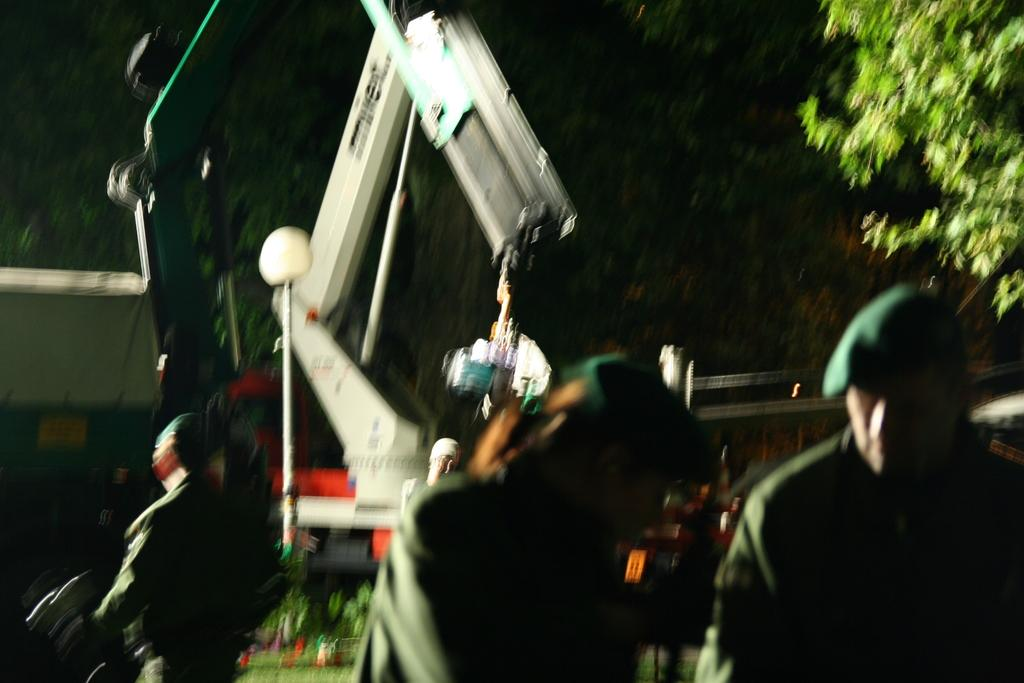How many people are in the image? There are persons in the image, but the exact number is not specified. What is the main object in the middle of the image? There is a crane in the middle of the image. What type of vegetation is on the right side of the image? There is a tree on the right side of the image. What color is the finger of the person holding the bike in the image? There is no person holding a bike in the image, nor is there any mention of a finger. 